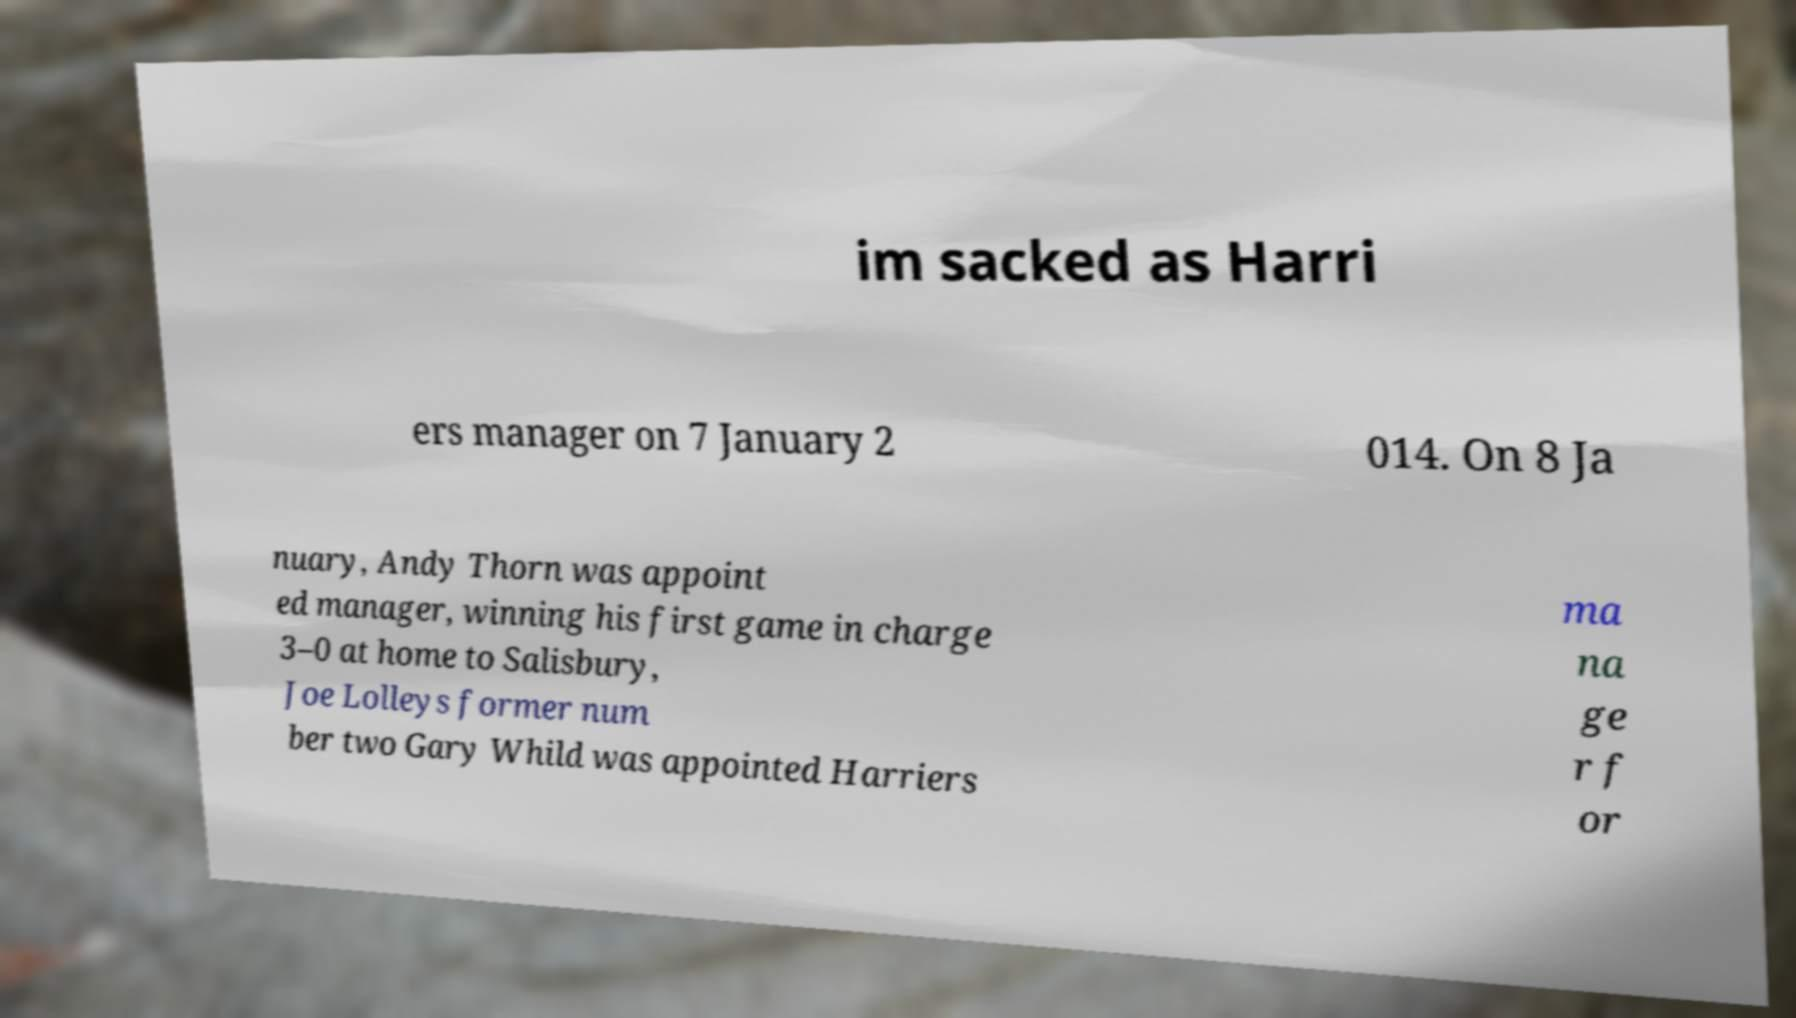I need the written content from this picture converted into text. Can you do that? im sacked as Harri ers manager on 7 January 2 014. On 8 Ja nuary, Andy Thorn was appoint ed manager, winning his first game in charge 3–0 at home to Salisbury, Joe Lolleys former num ber two Gary Whild was appointed Harriers ma na ge r f or 